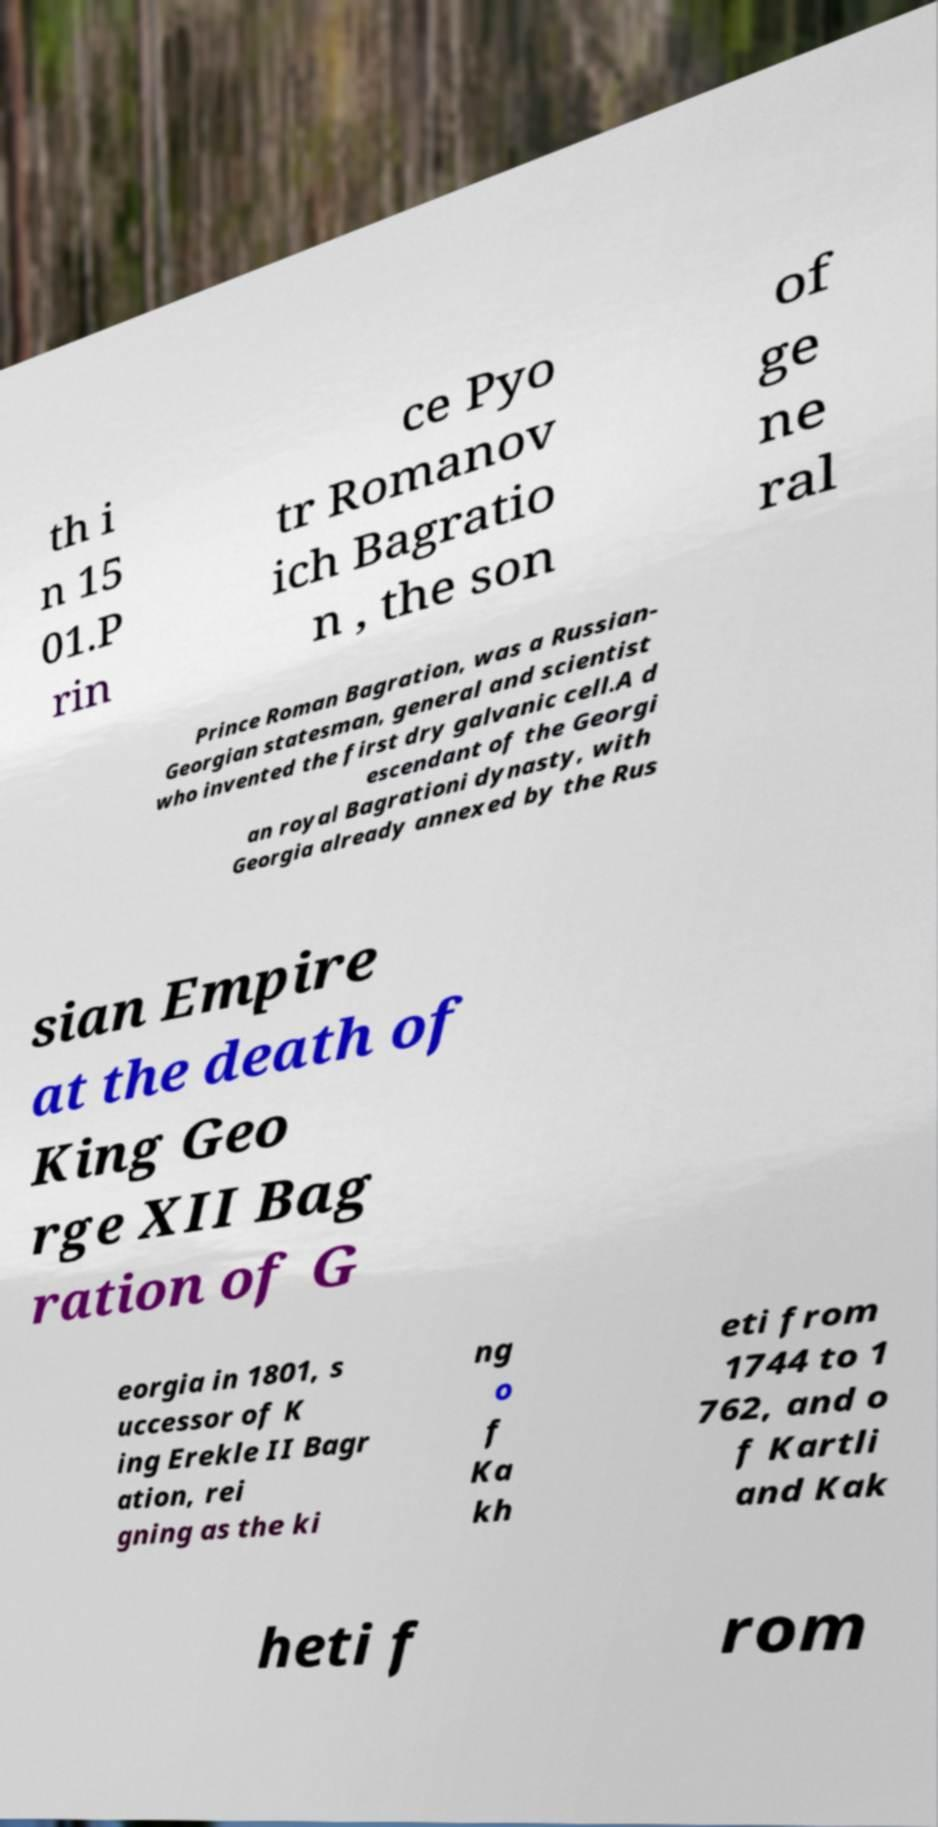I need the written content from this picture converted into text. Can you do that? th i n 15 01.P rin ce Pyo tr Romanov ich Bagratio n , the son of ge ne ral Prince Roman Bagration, was a Russian- Georgian statesman, general and scientist who invented the first dry galvanic cell.A d escendant of the Georgi an royal Bagrationi dynasty, with Georgia already annexed by the Rus sian Empire at the death of King Geo rge XII Bag ration of G eorgia in 1801, s uccessor of K ing Erekle II Bagr ation, rei gning as the ki ng o f Ka kh eti from 1744 to 1 762, and o f Kartli and Kak heti f rom 